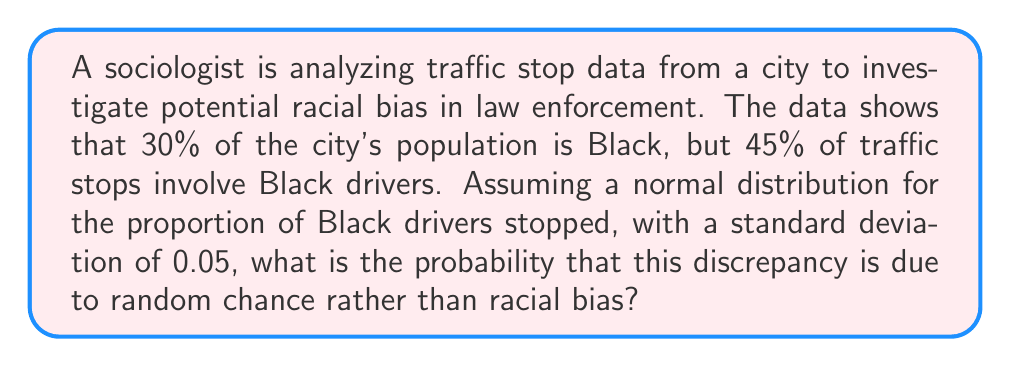Help me with this question. To solve this problem, we need to use the properties of the normal distribution and calculate a z-score. Here's a step-by-step approach:

1. Identify the key information:
   - Null hypothesis (H0): The proportion of Black drivers stopped is equal to the population proportion (30%)
   - Observed proportion: 45% of traffic stops involve Black drivers
   - Population proportion: 30% of the city's population is Black
   - Standard deviation: 0.05

2. Calculate the z-score:
   The z-score formula is: $z = \frac{x - \mu}{\sigma}$
   Where:
   $x$ = observed proportion = 0.45
   $\mu$ = population proportion = 0.30
   $\sigma$ = standard deviation = 0.05

   $$z = \frac{0.45 - 0.30}{0.05} = \frac{0.15}{0.05} = 3$$

3. Use the standard normal distribution table or calculator to find the probability:
   We want the probability of observing a z-score of 3 or higher by chance.
   This is a one-tailed test, so we need to find P(Z > 3).

4. Using a standard normal distribution table or calculator:
   P(Z > 3) ≈ 0.00135

5. Convert to a percentage:
   0.00135 * 100 = 0.135%

Therefore, the probability that this discrepancy is due to random chance rather than racial bias is approximately 0.135%.
Answer: 0.135% 